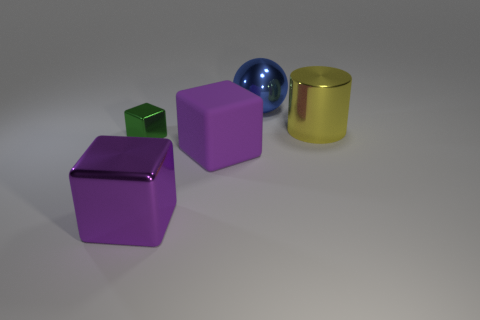Is there anything else that is the same size as the green thing?
Keep it short and to the point. No. There is a large cylinder; is its color the same as the object behind the big metallic cylinder?
Provide a succinct answer. No. How big is the thing that is behind the rubber thing and in front of the big yellow cylinder?
Offer a terse response. Small. Are there any big things behind the blue sphere?
Make the answer very short. No. Is there a big blue shiny thing that is in front of the metallic block that is on the right side of the green cube?
Your answer should be compact. No. Are there the same number of large metal spheres to the left of the yellow object and large purple blocks that are left of the ball?
Your answer should be compact. No. What is the color of the small cube that is made of the same material as the cylinder?
Provide a short and direct response. Green. Is there a large gray sphere made of the same material as the tiny green thing?
Offer a very short reply. No. What number of objects are large blue shiny balls or big blue matte balls?
Keep it short and to the point. 1. Does the big blue thing have the same material as the thing on the right side of the blue ball?
Your response must be concise. Yes. 